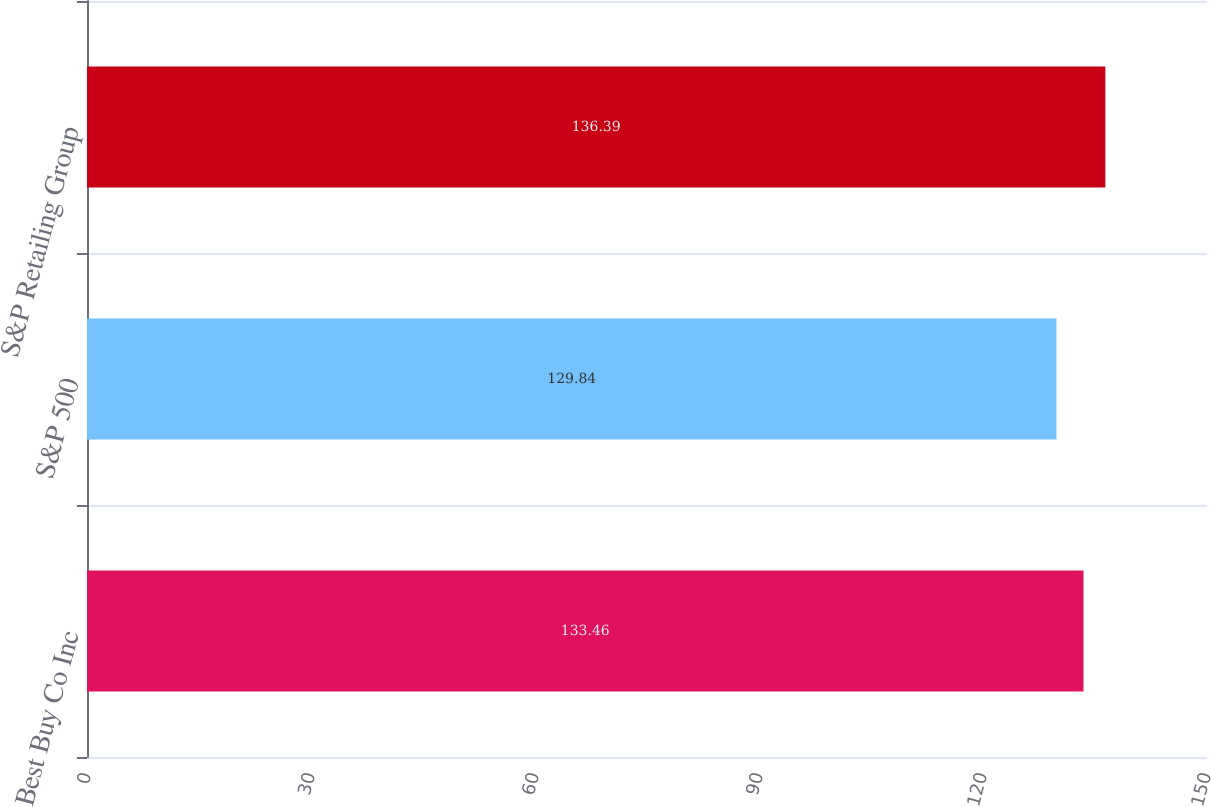<chart> <loc_0><loc_0><loc_500><loc_500><bar_chart><fcel>Best Buy Co Inc<fcel>S&P 500<fcel>S&P Retailing Group<nl><fcel>133.46<fcel>129.84<fcel>136.39<nl></chart> 